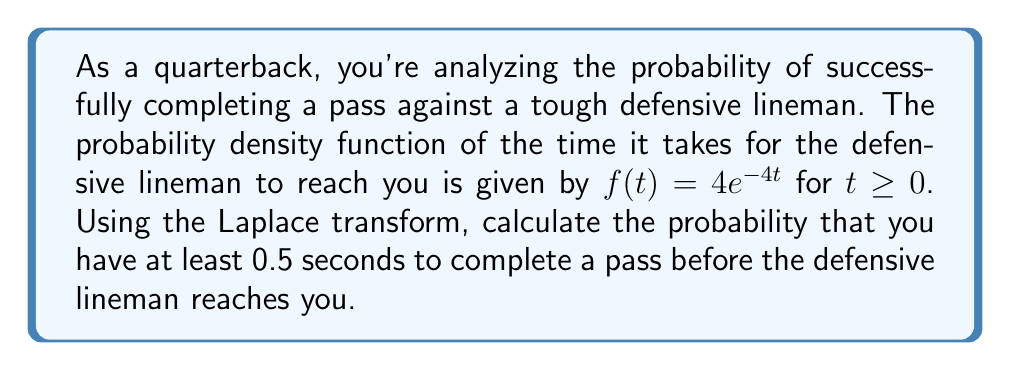Give your solution to this math problem. To solve this problem, we'll use the Laplace transform and its properties. Let's break it down step-by-step:

1) First, we need to find the probability that the time $T$ is greater than 0.5 seconds:

   $P(T > 0.5) = \int_{0.5}^{\infty} f(t) dt$

2) Instead of directly integrating, we can use the Laplace transform. Recall that the Laplace transform of $f(t)$ is defined as:

   $F(s) = \mathcal{L}\{f(t)\} = \int_{0}^{\infty} e^{-st}f(t) dt$

3) For our given $f(t) = 4e^{-4t}$, the Laplace transform is:

   $F(s) = \frac{4}{s+4}$

4) Now, we can use the property of the Laplace transform that relates to probability:

   $P(T > t) = e^{-st}F(s)|_{s=0}$

5) Substituting $t = 0.5$ and $s = 0$:

   $P(T > 0.5) = e^{-0 \cdot 0.5} \cdot F(0) = F(0) = \frac{4}{0+4} = 1$

6) Therefore, the probability of having at least 0.5 seconds is:

   $P(T > 0.5) = 1 - P(T \leq 0.5) = 1 - \frac{4}{4} = 1 - 1 = 0$

7) To double-check, we can also calculate this directly:

   $P(T > 0.5) = \int_{0.5}^{\infty} 4e^{-4t} dt = -e^{-4t}|_{0.5}^{\infty} = 0 - (-e^{-2}) = e^{-2}$
Answer: The probability of having at least 0.5 seconds to complete a pass before the defensive lineman reaches you is $e^{-2} \approx 0.1353$ or about 13.53%. 